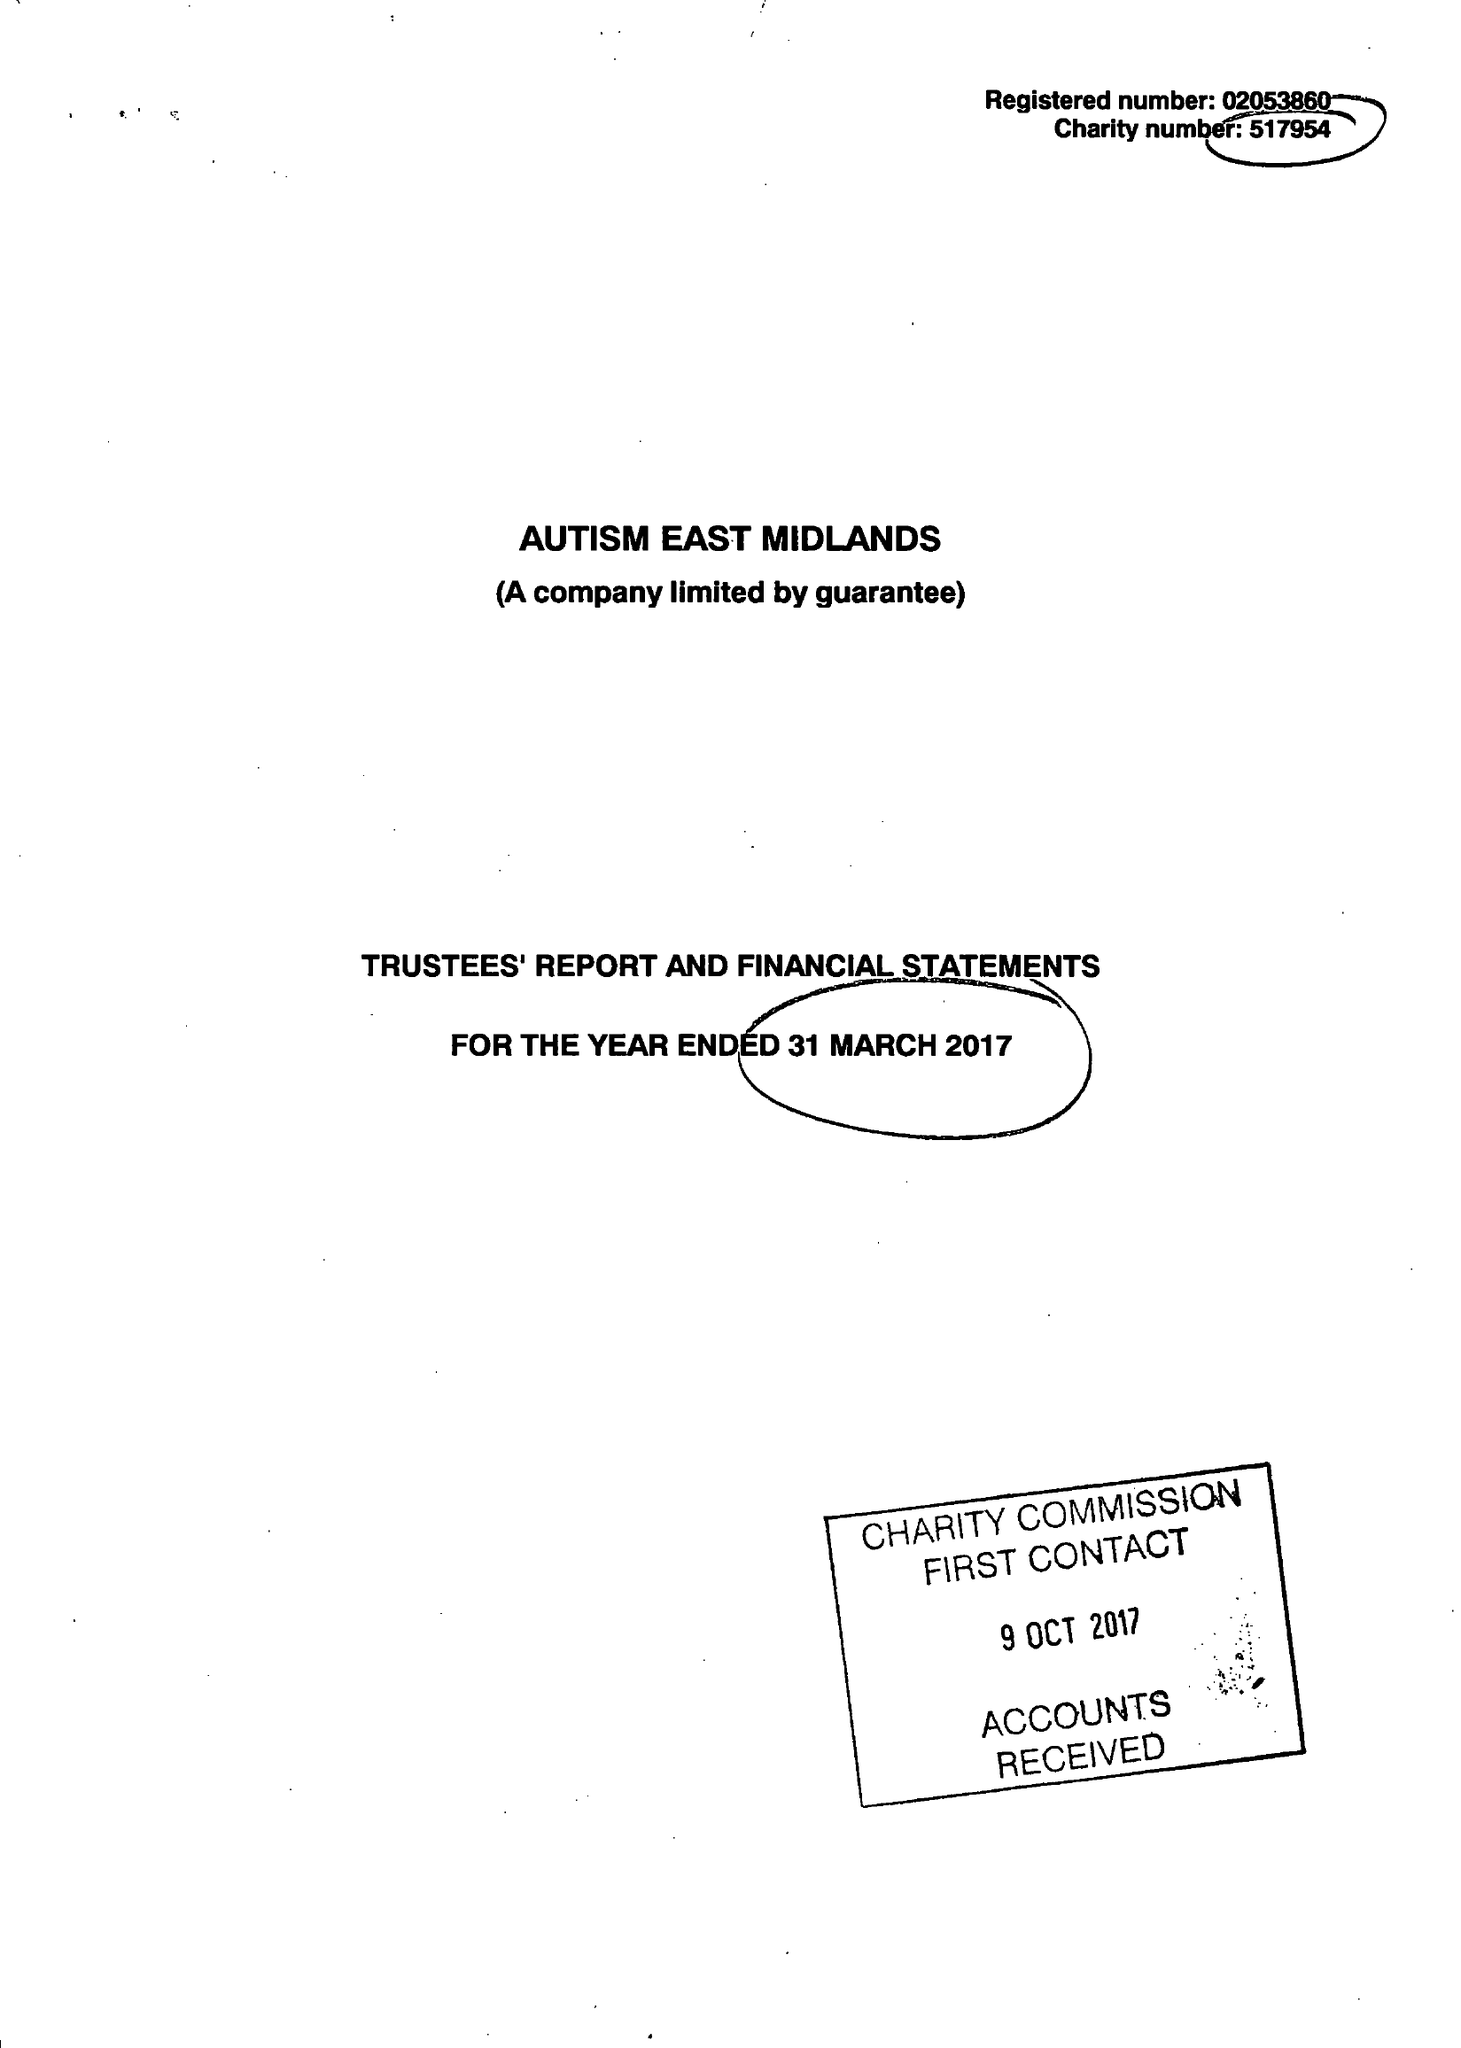What is the value for the address__post_town?
Answer the question using a single word or phrase. WORKSOP 